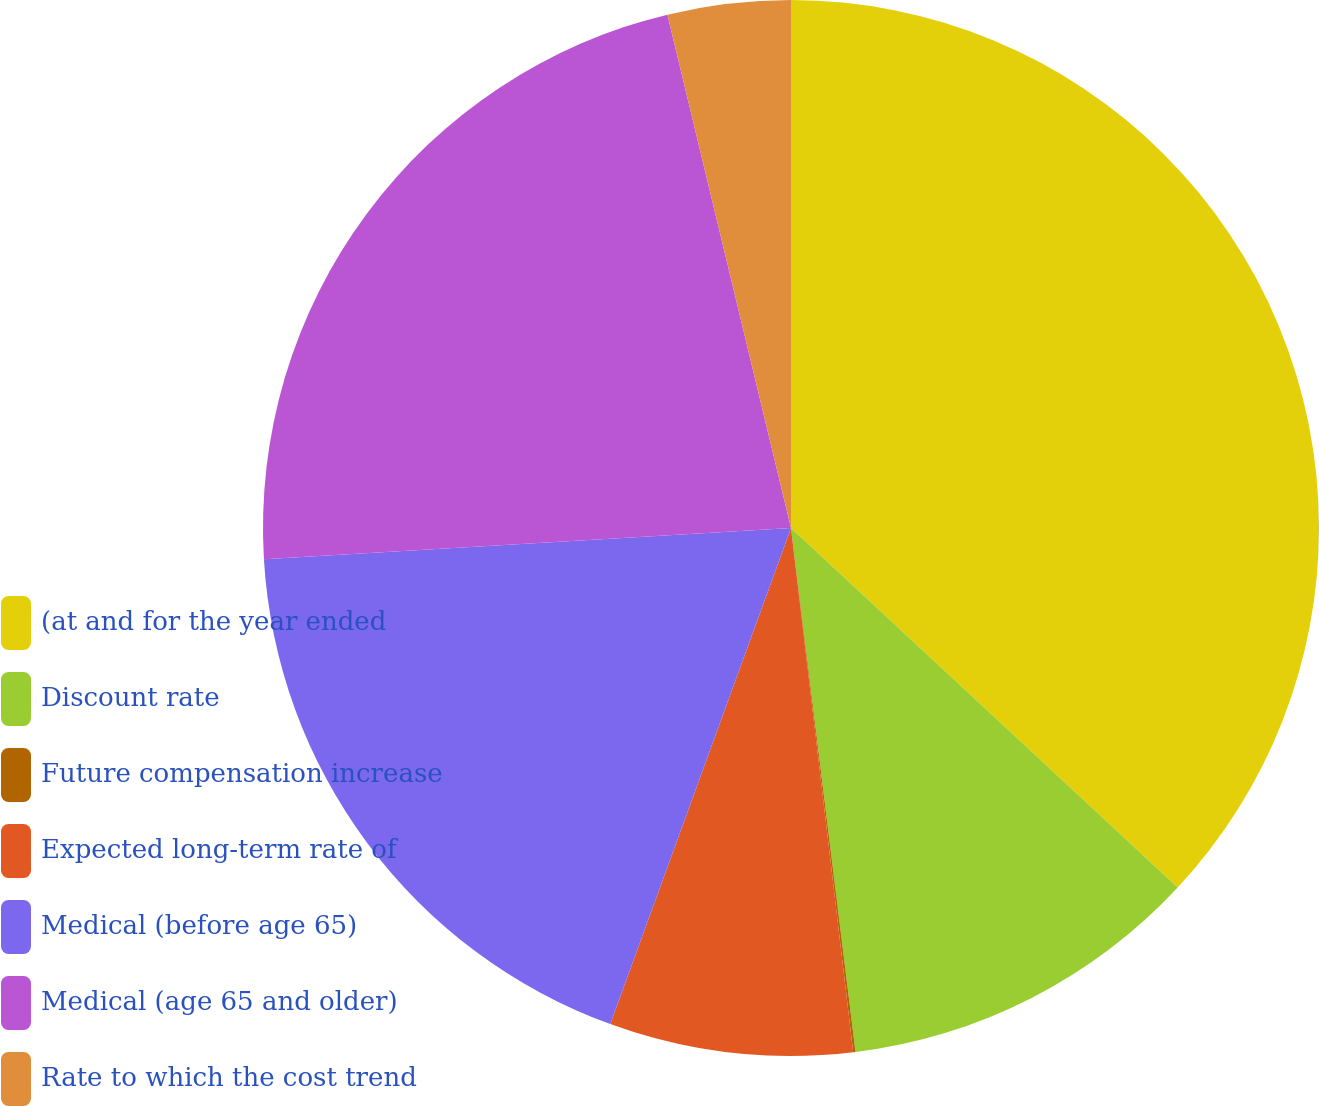Convert chart to OTSL. <chart><loc_0><loc_0><loc_500><loc_500><pie_chart><fcel>(at and for the year ended<fcel>Discount rate<fcel>Future compensation increase<fcel>Expected long-term rate of<fcel>Medical (before age 65)<fcel>Medical (age 65 and older)<fcel>Rate to which the cost trend<nl><fcel>36.92%<fcel>11.13%<fcel>0.07%<fcel>7.44%<fcel>18.5%<fcel>22.18%<fcel>3.76%<nl></chart> 